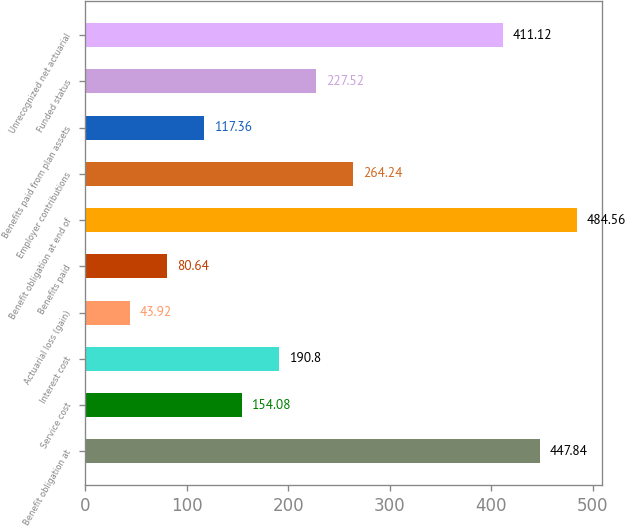<chart> <loc_0><loc_0><loc_500><loc_500><bar_chart><fcel>Benefit obligation at<fcel>Service cost<fcel>Interest cost<fcel>Actuarial loss (gain)<fcel>Benefits paid<fcel>Benefit obligation at end of<fcel>Employer contributions<fcel>Benefits paid from plan assets<fcel>Funded status<fcel>Unrecognized net actuarial<nl><fcel>447.84<fcel>154.08<fcel>190.8<fcel>43.92<fcel>80.64<fcel>484.56<fcel>264.24<fcel>117.36<fcel>227.52<fcel>411.12<nl></chart> 